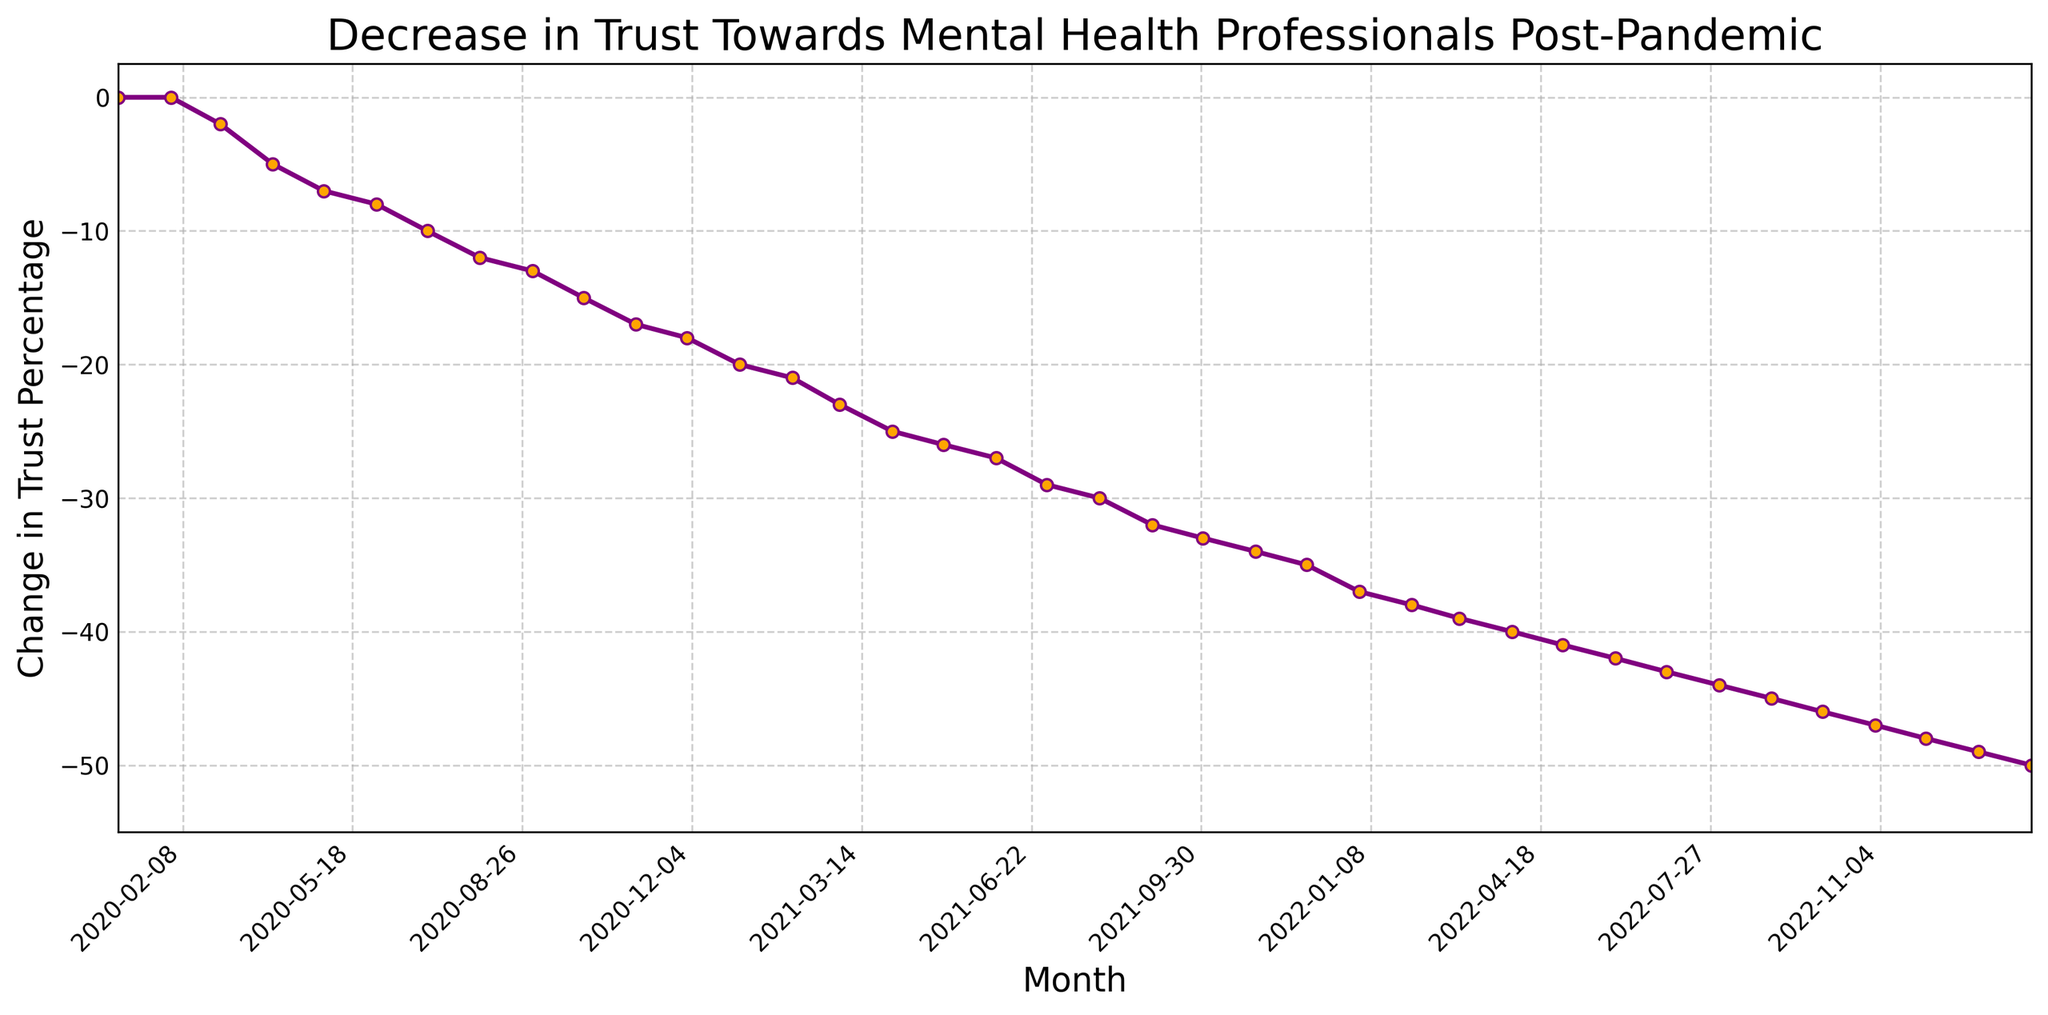When did the largest month-over-month decrease in trust occur? Identify the month with the highest negative change between consecutive months. The most significant drop is between January 2023 (-49) and February 2023 (-50), which is 1%, compared to earlier months with higher differences.
Answer: February 2023 Which month had the first recorded decrease in trust? Identify from the data the first month where the trust change percentage is negative.
Answer: March 2020 How much did trust change from January 2021 to January 2022? Look at the trust change percentage in January 2021 (-20) and January 2022 (-37) and calculate the difference: -37 - (-20) = -17.
Answer: -17% What was the percentage change in trust from June 2021 to November 2021? Note the trust change percentages: June 2021 (-27) and November 2021 (-34) and calculate the difference: -34 - (-27) = -7.
Answer: -7% Which month experienced the least amount of change within the first year of data? Among months from January 2020 to December 2020, find the pairs of consecutive months with the smallest difference in trust change percentage: November 2020 (-17) to December 2020 (-18) shows the smallest change of -1.
Answer: December 2020 What is the visual pattern displayed by the line chart? Notice the downward trend, indicating a decrease in trust, with occasional sharp drops and a steady decline.
Answer: Steady decrease with occasional sharp drops How does the trust change in December 2020 compare to December 2021? Compare the trust change percentages: December 2020 (-18) and December 2021 (-35). The difference is (-35) - (-18) = -17.
Answer: December 2021 is 17% more negative What general trend do you observe from January 2020 to February 2023 on the graph? Observe the overall decline in the trust change percentage starting from zero in January 2020 to -50 in February 2023.
Answer: Steady decline 